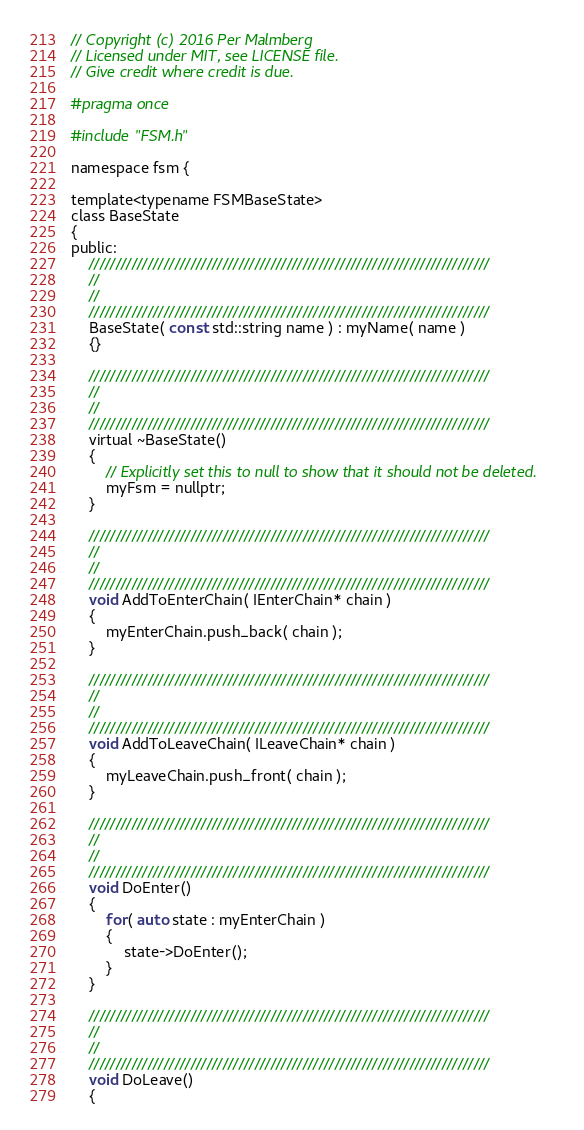Convert code to text. <code><loc_0><loc_0><loc_500><loc_500><_C_>// Copyright (c) 2016 Per Malmberg
// Licensed under MIT, see LICENSE file.
// Give credit where credit is due.

#pragma once

#include "FSM.h"

namespace fsm {

template<typename FSMBaseState>
class BaseState
{
public:
	///////////////////////////////////////////////////////////////////////////
	//
	//
	///////////////////////////////////////////////////////////////////////////
	BaseState( const std::string name ) : myName( name )
	{}

	///////////////////////////////////////////////////////////////////////////
	//
	//
	///////////////////////////////////////////////////////////////////////////
	virtual ~BaseState()
	{
		// Explicitly set this to null to show that it should not be deleted.
		myFsm = nullptr;
	}

	///////////////////////////////////////////////////////////////////////////
	//
	//
	///////////////////////////////////////////////////////////////////////////
	void AddToEnterChain( IEnterChain* chain )
	{
		myEnterChain.push_back( chain );
	}

	///////////////////////////////////////////////////////////////////////////
	//
	//
	///////////////////////////////////////////////////////////////////////////
	void AddToLeaveChain( ILeaveChain* chain )
	{
		myLeaveChain.push_front( chain );
	}

	///////////////////////////////////////////////////////////////////////////
	//
	//
	///////////////////////////////////////////////////////////////////////////
	void DoEnter()
	{
		for( auto state : myEnterChain )
		{
			state->DoEnter();
		}
	}

	///////////////////////////////////////////////////////////////////////////
	//
	//
	///////////////////////////////////////////////////////////////////////////
	void DoLeave()
	{</code> 